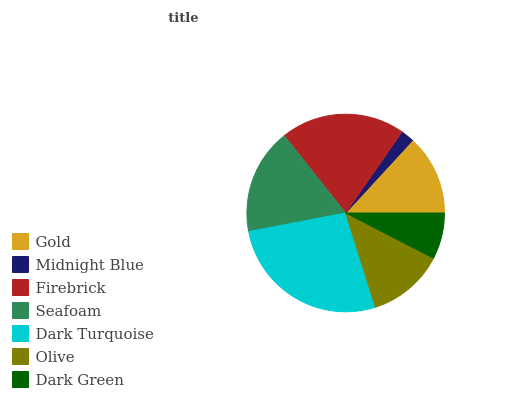Is Midnight Blue the minimum?
Answer yes or no. Yes. Is Dark Turquoise the maximum?
Answer yes or no. Yes. Is Firebrick the minimum?
Answer yes or no. No. Is Firebrick the maximum?
Answer yes or no. No. Is Firebrick greater than Midnight Blue?
Answer yes or no. Yes. Is Midnight Blue less than Firebrick?
Answer yes or no. Yes. Is Midnight Blue greater than Firebrick?
Answer yes or no. No. Is Firebrick less than Midnight Blue?
Answer yes or no. No. Is Gold the high median?
Answer yes or no. Yes. Is Gold the low median?
Answer yes or no. Yes. Is Dark Green the high median?
Answer yes or no. No. Is Seafoam the low median?
Answer yes or no. No. 